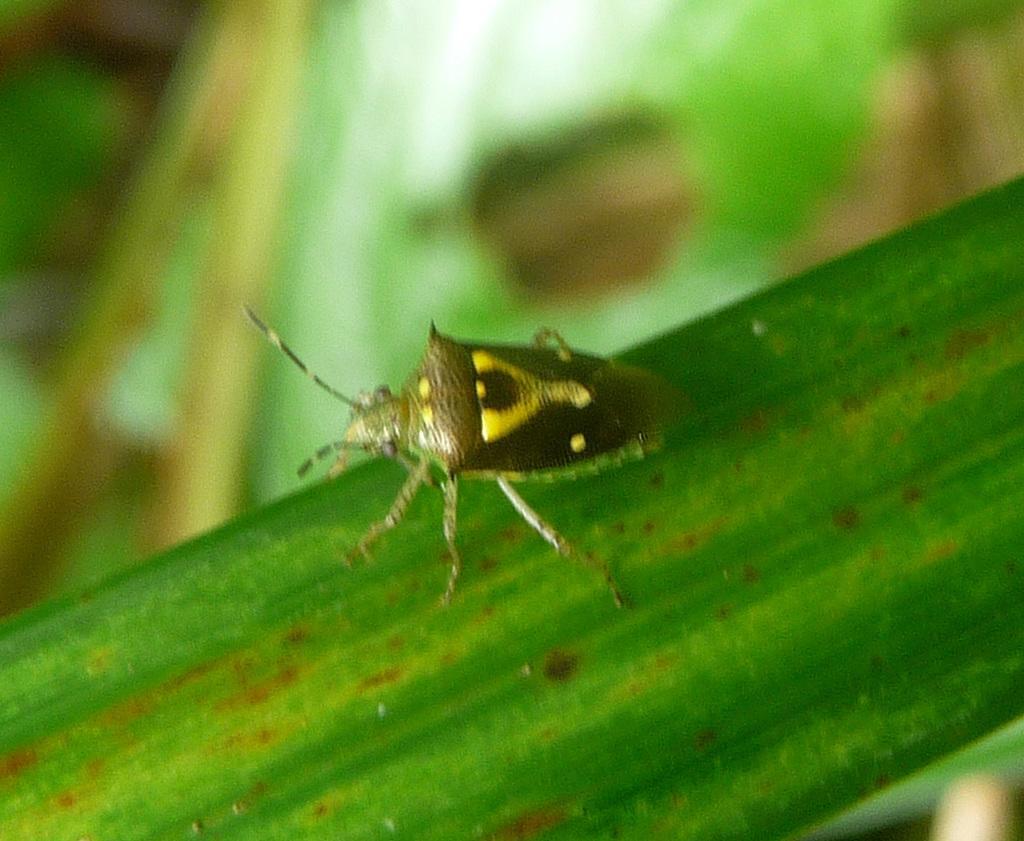How would you summarize this image in a sentence or two? In this image I can see a green colour thing in the front and on it I can see an insect. I can see colour of the insect is brown and yellow and I can see this image is little bit blurry in the background. 